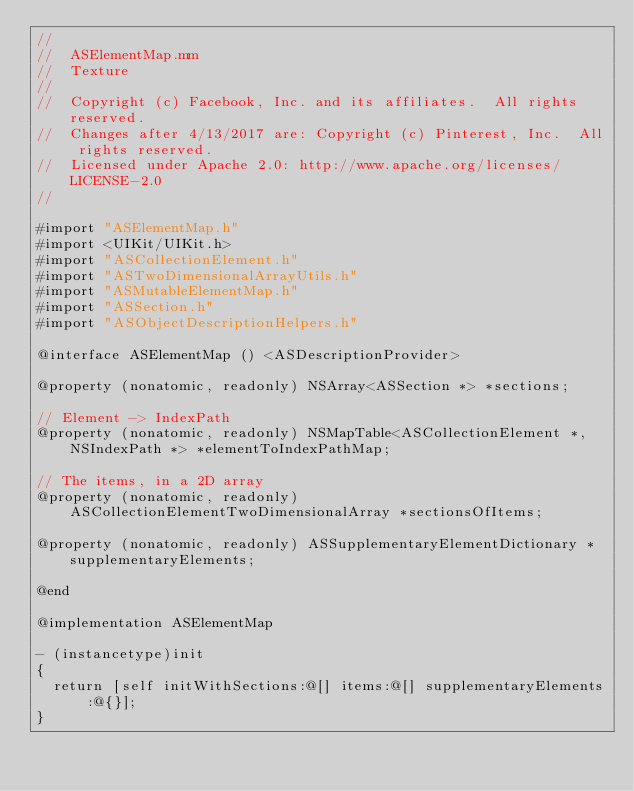Convert code to text. <code><loc_0><loc_0><loc_500><loc_500><_ObjectiveC_>//
//  ASElementMap.mm
//  Texture
//
//  Copyright (c) Facebook, Inc. and its affiliates.  All rights reserved.
//  Changes after 4/13/2017 are: Copyright (c) Pinterest, Inc.  All rights reserved.
//  Licensed under Apache 2.0: http://www.apache.org/licenses/LICENSE-2.0
//

#import "ASElementMap.h"
#import <UIKit/UIKit.h>
#import "ASCollectionElement.h"
#import "ASTwoDimensionalArrayUtils.h"
#import "ASMutableElementMap.h"
#import "ASSection.h"
#import "ASObjectDescriptionHelpers.h"

@interface ASElementMap () <ASDescriptionProvider>

@property (nonatomic, readonly) NSArray<ASSection *> *sections;

// Element -> IndexPath
@property (nonatomic, readonly) NSMapTable<ASCollectionElement *, NSIndexPath *> *elementToIndexPathMap;

// The items, in a 2D array
@property (nonatomic, readonly) ASCollectionElementTwoDimensionalArray *sectionsOfItems;

@property (nonatomic, readonly) ASSupplementaryElementDictionary *supplementaryElements;

@end

@implementation ASElementMap

- (instancetype)init
{
  return [self initWithSections:@[] items:@[] supplementaryElements:@{}];
}
</code> 